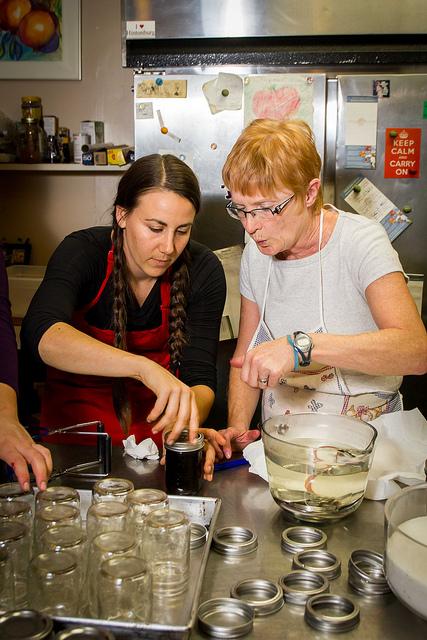What are the women doing?
Write a very short answer. Canning. What are the silver rings on the table for?
Be succinct. Lids for jars. How many women are wearing glasses?
Quick response, please. 1. What is there a lot of on the table?
Write a very short answer. Jars. 